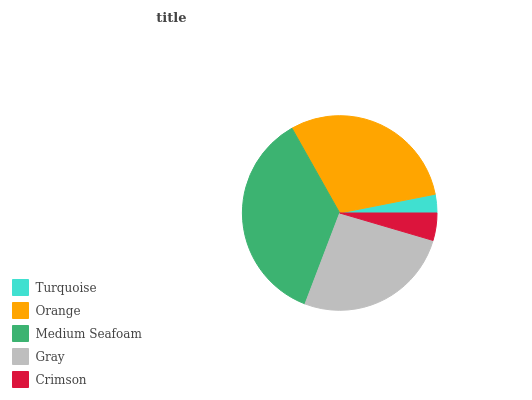Is Turquoise the minimum?
Answer yes or no. Yes. Is Medium Seafoam the maximum?
Answer yes or no. Yes. Is Orange the minimum?
Answer yes or no. No. Is Orange the maximum?
Answer yes or no. No. Is Orange greater than Turquoise?
Answer yes or no. Yes. Is Turquoise less than Orange?
Answer yes or no. Yes. Is Turquoise greater than Orange?
Answer yes or no. No. Is Orange less than Turquoise?
Answer yes or no. No. Is Gray the high median?
Answer yes or no. Yes. Is Gray the low median?
Answer yes or no. Yes. Is Medium Seafoam the high median?
Answer yes or no. No. Is Orange the low median?
Answer yes or no. No. 